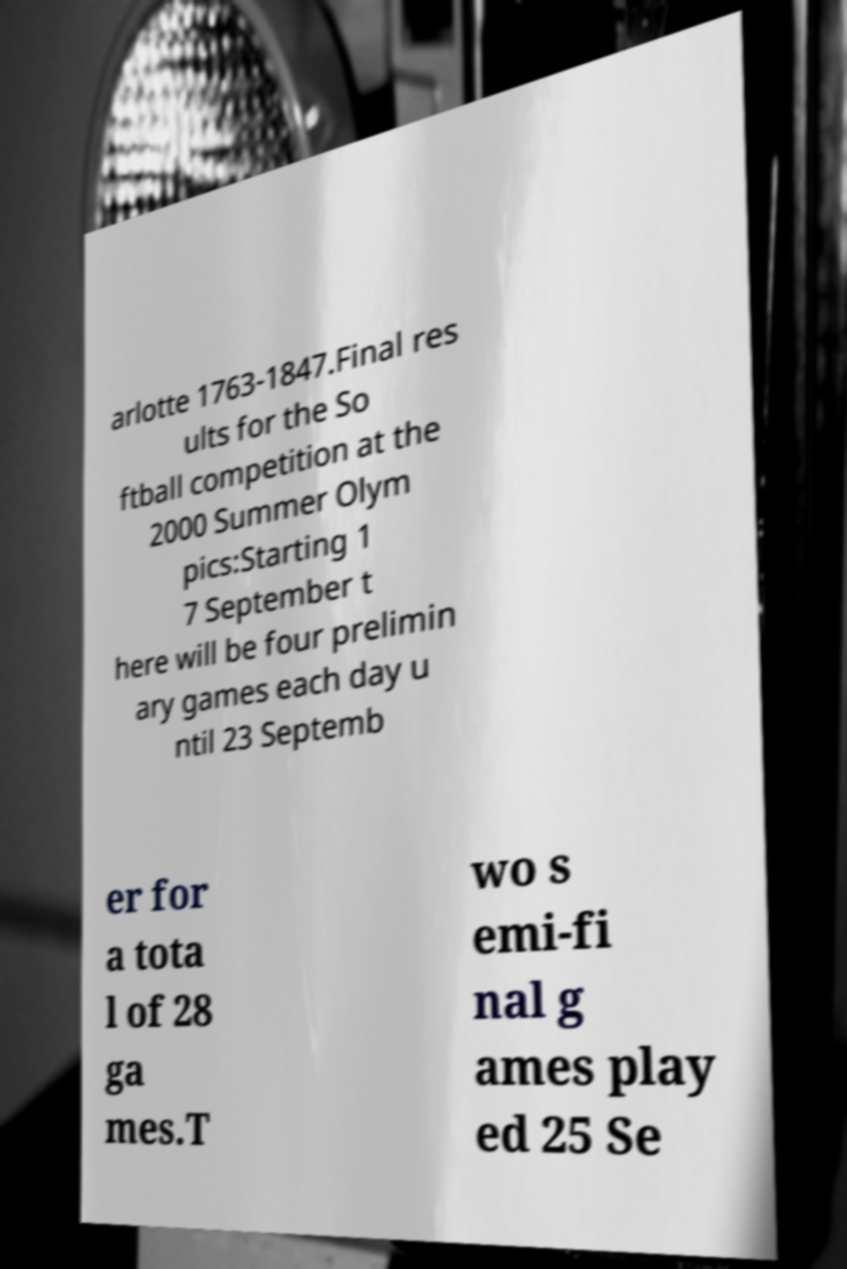Could you assist in decoding the text presented in this image and type it out clearly? arlotte 1763-1847.Final res ults for the So ftball competition at the 2000 Summer Olym pics:Starting 1 7 September t here will be four prelimin ary games each day u ntil 23 Septemb er for a tota l of 28 ga mes.T wo s emi-fi nal g ames play ed 25 Se 